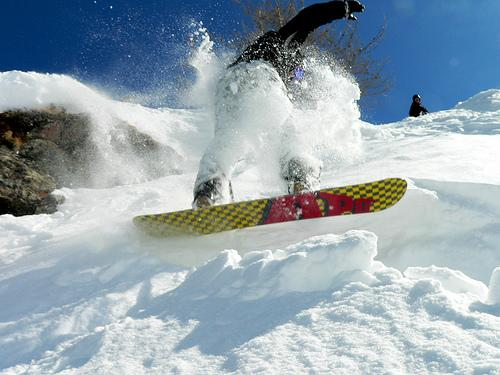What are the colors and pattern on the snowboard, and are there any letters on it? The snowboard has a yellow and black checkerboard pattern with red and gray letters on the bottom. What is the position of the snowboard and snowboarder in the air? The snowboard is airborne and the snowboarder is wearing gloves, black jacket, and performing a trick. Detail any safety gear or equipment that the person on the snowboard is wearing. The snowboarder is wearing a helmet, black gloves, and snowboarding boots for safety and protection. Write a sentence describing the snow on the mountain. White snow covers the mountain, with shadows cast on it, and a chunk of snow atop indicates deep snow conditions. Provide a brief description of the person snowboarding and what they are wearing. A person is snowboarding wearing a black jacket, black gloves, snow pants, and boots on a checked snowboard. Mention any other person present in the scene. A person wearing a helmet stands in the snow on top of a hill, watching the snowboarder in action. Describe the surrounding environment where this person is snowboarding. The person is snowboarding on a mountain with white snow, exposed rocks, and trees with another person looking on. Describe any weather elements that can be observed in the image. Blue skies can be seen in the background with white snow on the ground and splashed snow in the air. Describe the trees and rocks visible in the image. There are trees on the mountain above the snowboarder, branches in the background, and rocks sticking out of the snow. In a short sentence, describe the overall scene captured in the image. A snowboarder is performing a trick on a checked snowboard on a snowy mountain, with an onlooker in the distance. 